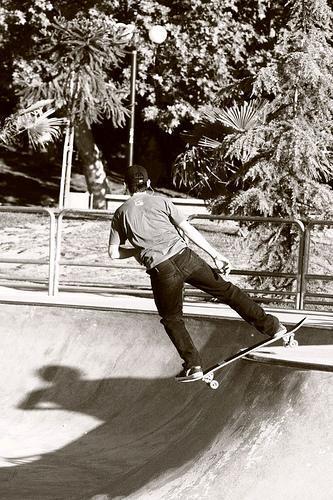How many fingers does the man have?
Give a very brief answer. 10. How many already fried donuts are there in the image?
Give a very brief answer. 0. 